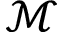<formula> <loc_0><loc_0><loc_500><loc_500>\ m a t h s c r { M }</formula> 